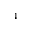<formula> <loc_0><loc_0><loc_500><loc_500>^ { 4 }</formula> 